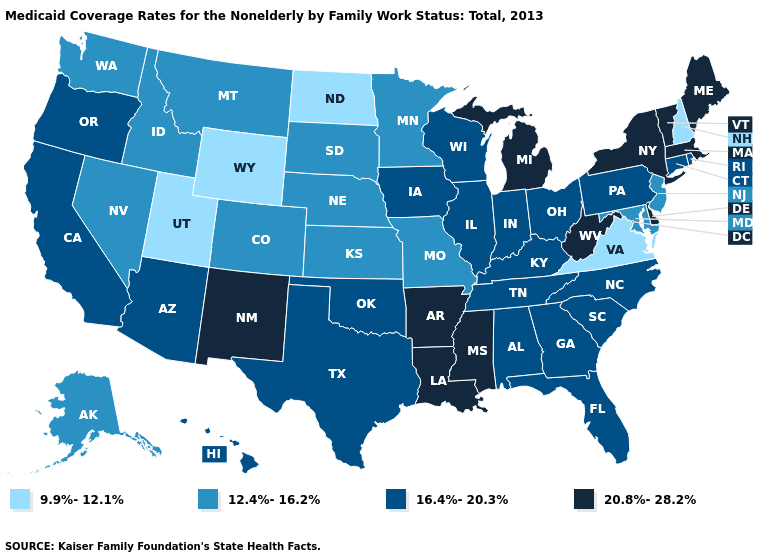What is the lowest value in states that border North Dakota?
Short answer required. 12.4%-16.2%. What is the value of Pennsylvania?
Keep it brief. 16.4%-20.3%. Name the states that have a value in the range 12.4%-16.2%?
Give a very brief answer. Alaska, Colorado, Idaho, Kansas, Maryland, Minnesota, Missouri, Montana, Nebraska, Nevada, New Jersey, South Dakota, Washington. What is the value of Montana?
Write a very short answer. 12.4%-16.2%. Among the states that border Oklahoma , does Colorado have the lowest value?
Quick response, please. Yes. What is the value of Delaware?
Write a very short answer. 20.8%-28.2%. Which states hav the highest value in the South?
Concise answer only. Arkansas, Delaware, Louisiana, Mississippi, West Virginia. Name the states that have a value in the range 9.9%-12.1%?
Write a very short answer. New Hampshire, North Dakota, Utah, Virginia, Wyoming. Name the states that have a value in the range 20.8%-28.2%?
Quick response, please. Arkansas, Delaware, Louisiana, Maine, Massachusetts, Michigan, Mississippi, New Mexico, New York, Vermont, West Virginia. What is the value of Louisiana?
Answer briefly. 20.8%-28.2%. What is the lowest value in the USA?
Concise answer only. 9.9%-12.1%. Does Oregon have a higher value than Alabama?
Keep it brief. No. Does the first symbol in the legend represent the smallest category?
Short answer required. Yes. Does Georgia have the same value as Kansas?
Write a very short answer. No. 